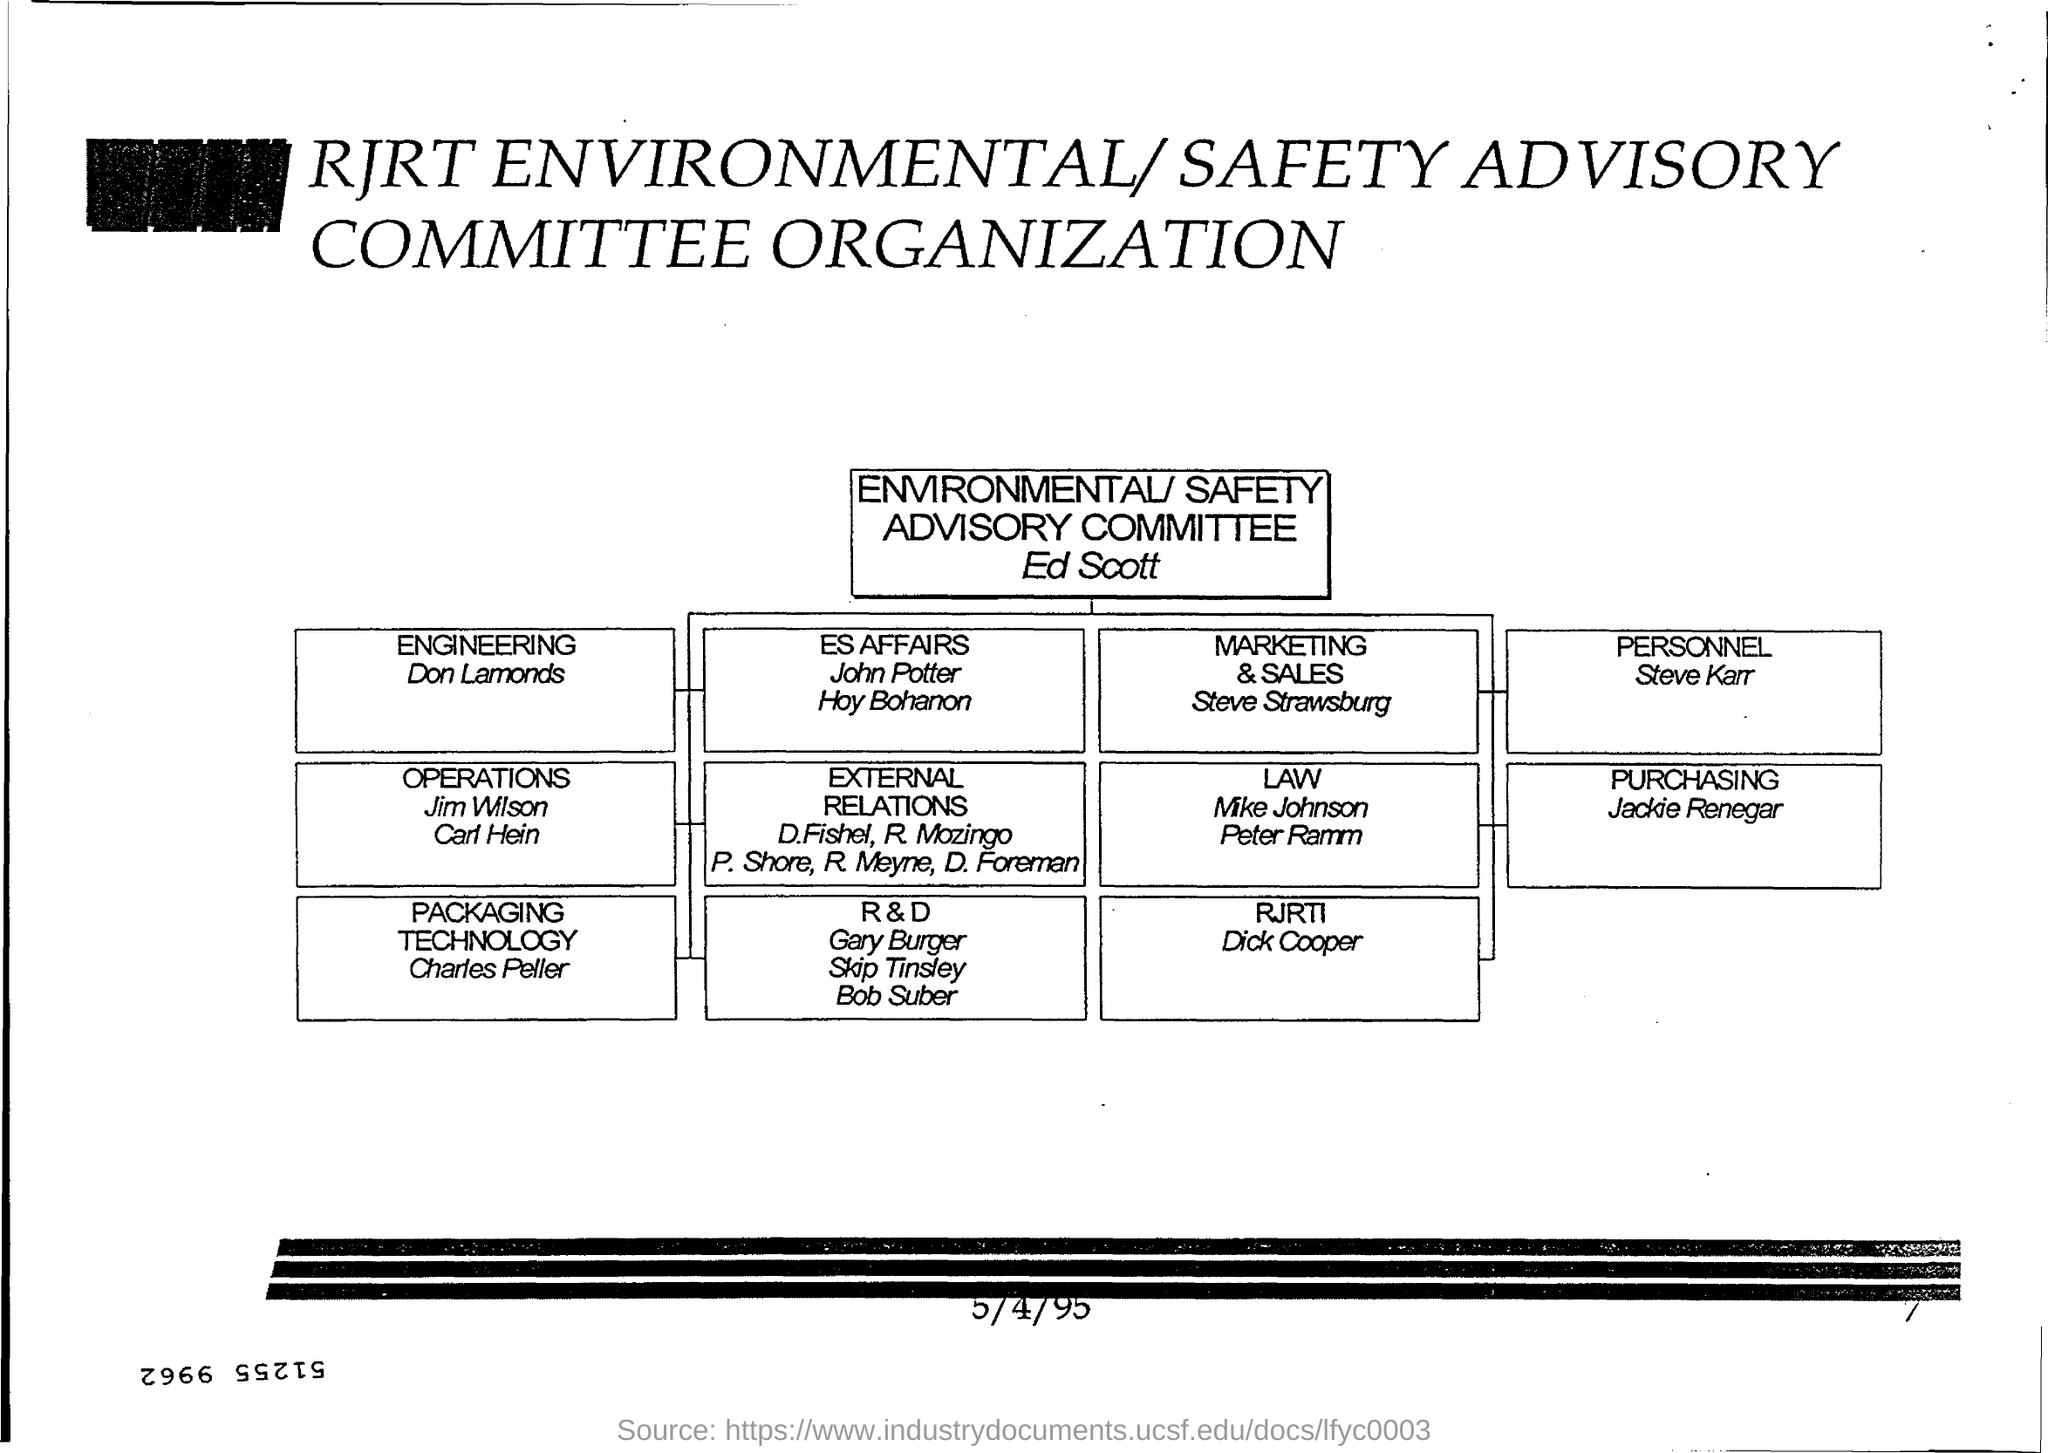Draw attention to some important aspects in this diagram. Charles Peller belongs to the packaging technology department. The person named Don Lamonds is associated with the field of engineering. The number at the bottom right corner of the page is 7. Please provide the date located at the bottom of the page, which is 5/4/95. 